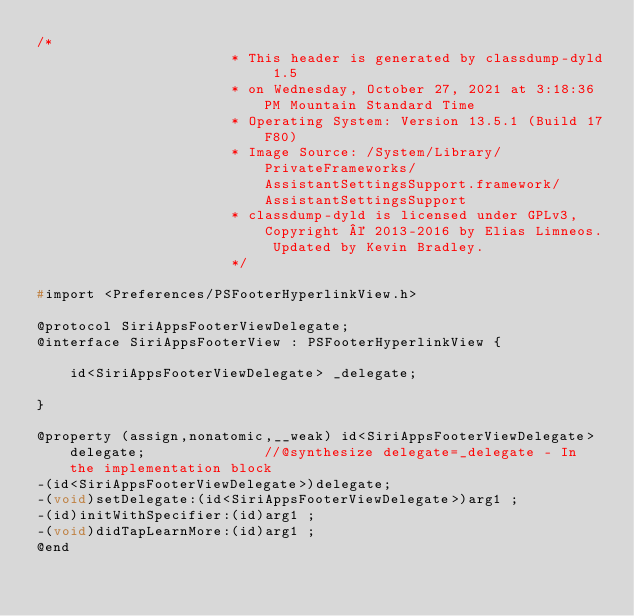<code> <loc_0><loc_0><loc_500><loc_500><_C_>/*
                       * This header is generated by classdump-dyld 1.5
                       * on Wednesday, October 27, 2021 at 3:18:36 PM Mountain Standard Time
                       * Operating System: Version 13.5.1 (Build 17F80)
                       * Image Source: /System/Library/PrivateFrameworks/AssistantSettingsSupport.framework/AssistantSettingsSupport
                       * classdump-dyld is licensed under GPLv3, Copyright © 2013-2016 by Elias Limneos. Updated by Kevin Bradley.
                       */

#import <Preferences/PSFooterHyperlinkView.h>

@protocol SiriAppsFooterViewDelegate;
@interface SiriAppsFooterView : PSFooterHyperlinkView {

	id<SiriAppsFooterViewDelegate> _delegate;

}

@property (assign,nonatomic,__weak) id<SiriAppsFooterViewDelegate> delegate;              //@synthesize delegate=_delegate - In the implementation block
-(id<SiriAppsFooterViewDelegate>)delegate;
-(void)setDelegate:(id<SiriAppsFooterViewDelegate>)arg1 ;
-(id)initWithSpecifier:(id)arg1 ;
-(void)didTapLearnMore:(id)arg1 ;
@end

</code> 